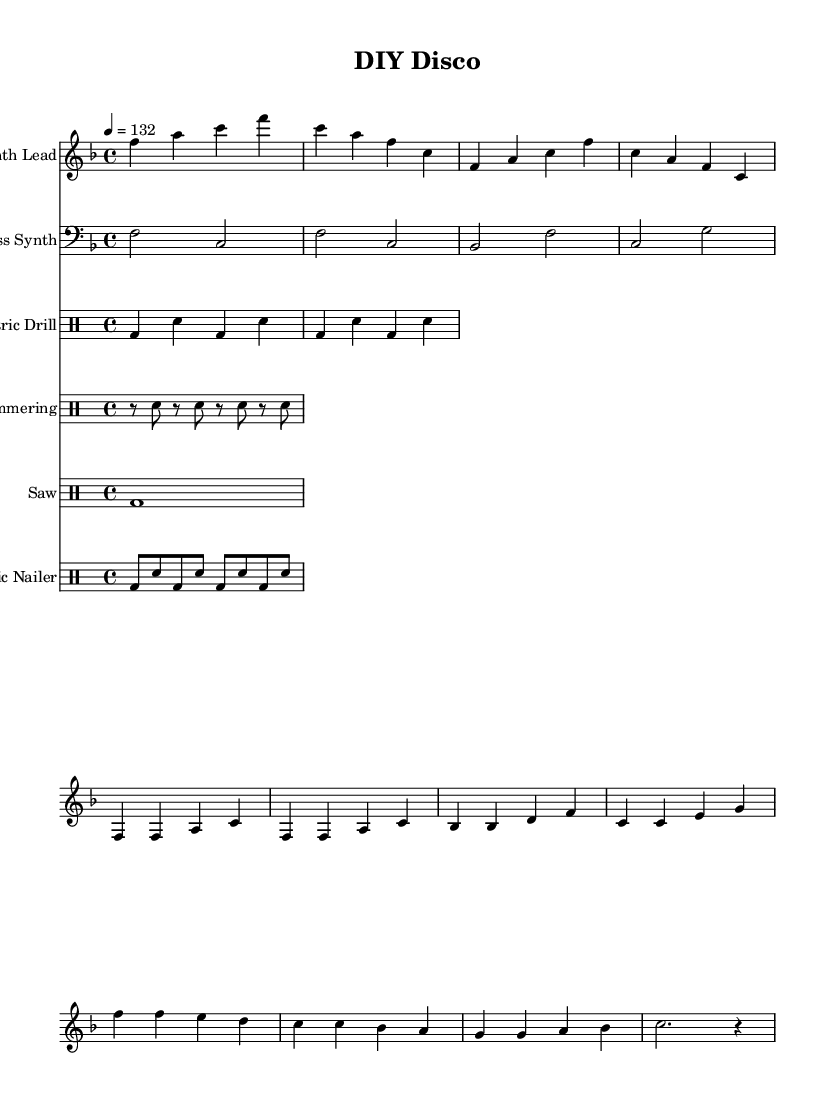What is the key signature of this music? The key signature is indicated at the beginning of the staff and has one flat, which corresponds to the key of F major.
Answer: F major What is the time signature of the piece? The time signature is found at the beginning of the score, showing four beats per measure and is represented as 4/4.
Answer: 4/4 What is the tempo marking given in the music? The tempo marking is specified above the first staff with the instruction to play at a speed of 132 beats per minute, using quarter note = 132.
Answer: 132 How many different instrumental parts are present in the score? To find the number of parts, we can count the distinct staves listed in the score. There are five staves labeled as Synth Lead, Bass Synth, Electric Drill, Hammering, Saw, and Pneumatic Nailer, making a total of six parts.
Answer: Six What rhythmic element does the electric drill represent in the music? The electric drill part uses bass drum and snare patterns to establish a primary rhythmic foundation, covering both beats and accents. Each measure alternates between different drum hits, creating a driving rhythm.
Answer: Rhythmic foundation In the chorus, what is the function of the pneumatic nailer in the music? The pneumatic nailer part contributes to the energetic texture of the chorus by playing a staccato rhythm with alternating bass and snare hits in a quick sequence throughout the measures. This creates a dynamic and lively effect supporting the main theme.
Answer: Dynamic texture 